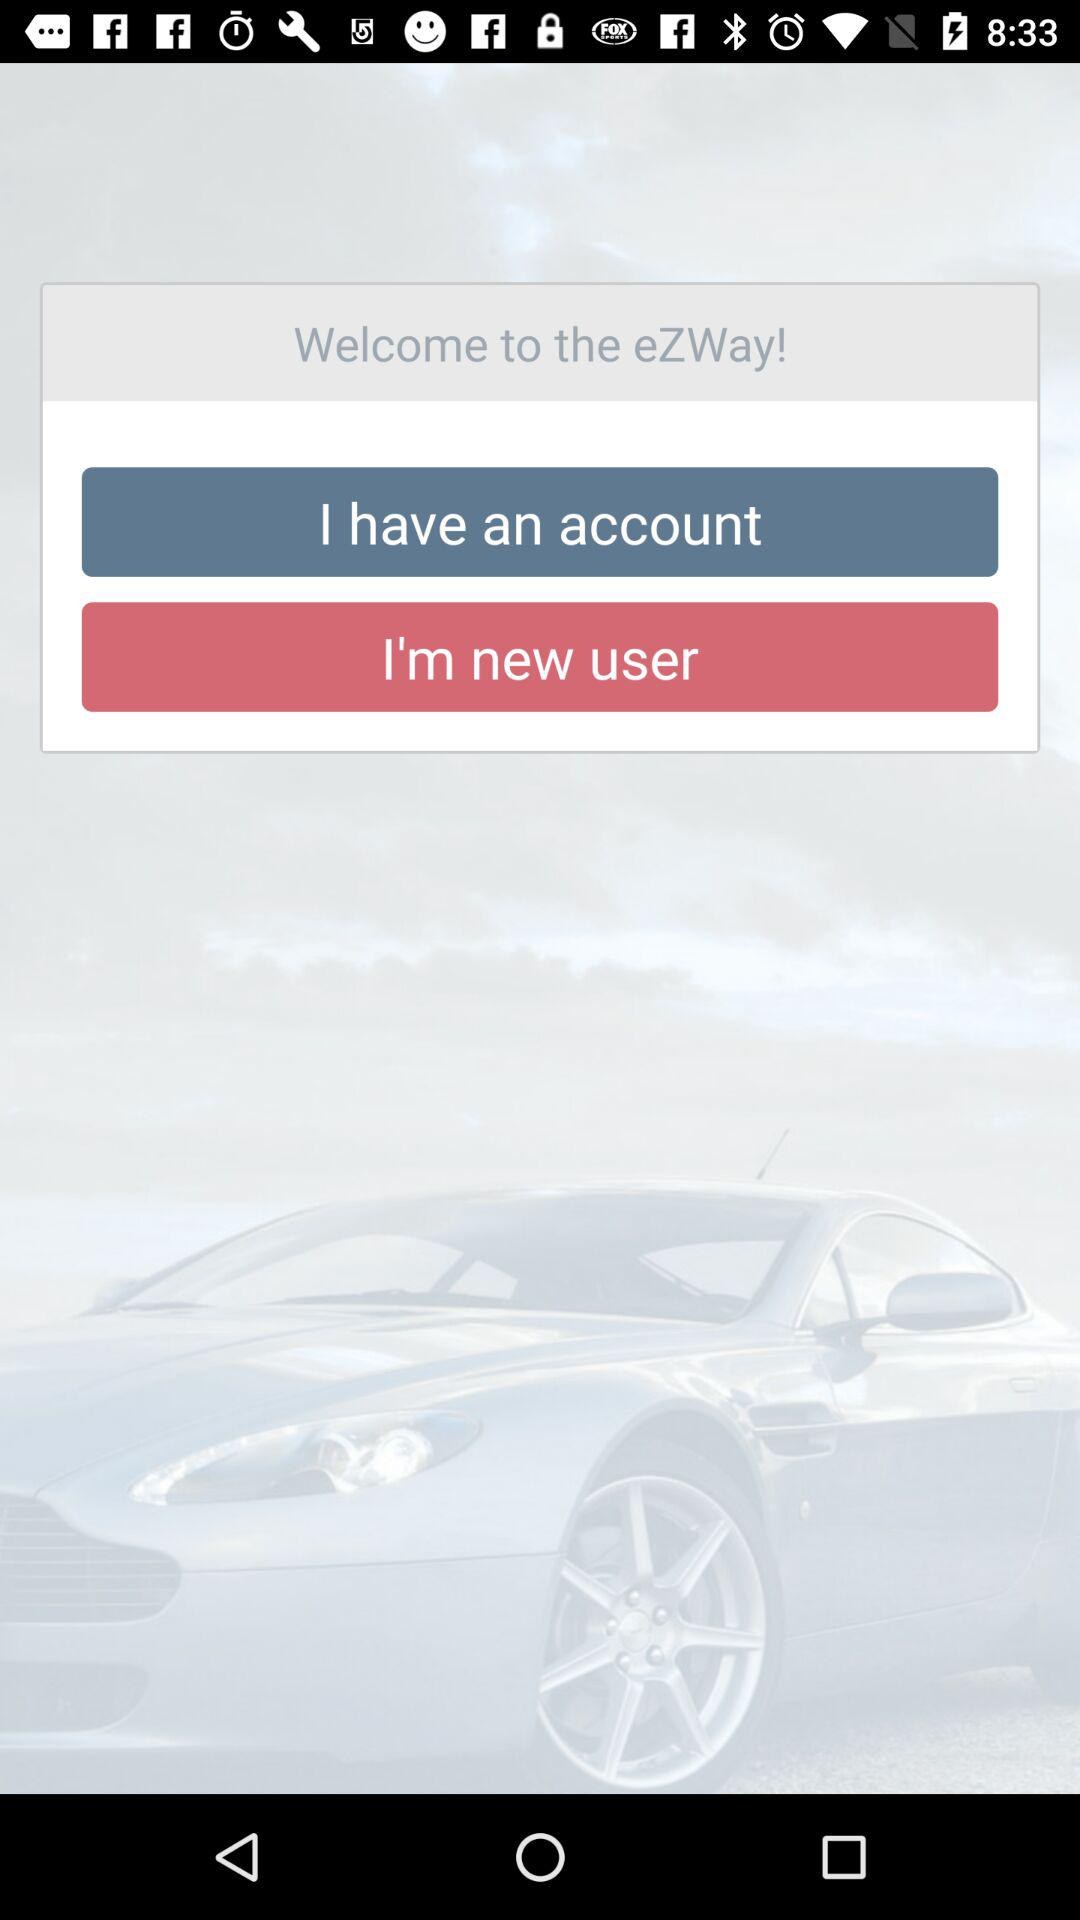What is the application name? The application name is "eZWay". 